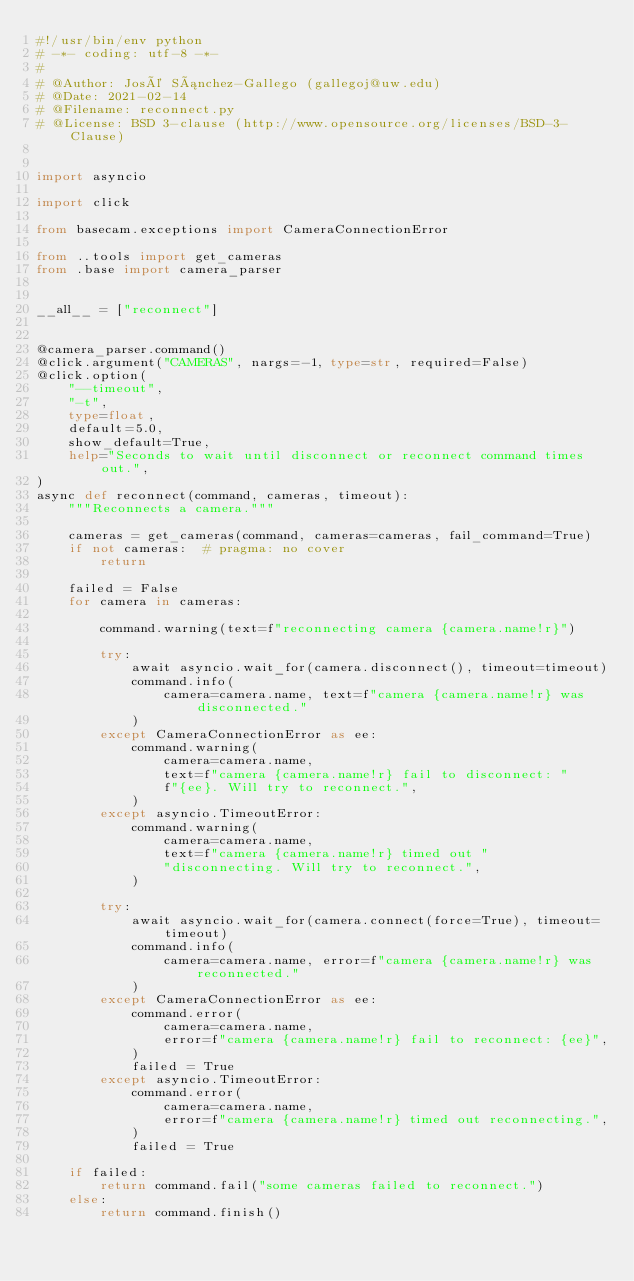Convert code to text. <code><loc_0><loc_0><loc_500><loc_500><_Python_>#!/usr/bin/env python
# -*- coding: utf-8 -*-
#
# @Author: José Sánchez-Gallego (gallegoj@uw.edu)
# @Date: 2021-02-14
# @Filename: reconnect.py
# @License: BSD 3-clause (http://www.opensource.org/licenses/BSD-3-Clause)


import asyncio

import click

from basecam.exceptions import CameraConnectionError

from ..tools import get_cameras
from .base import camera_parser


__all__ = ["reconnect"]


@camera_parser.command()
@click.argument("CAMERAS", nargs=-1, type=str, required=False)
@click.option(
    "--timeout",
    "-t",
    type=float,
    default=5.0,
    show_default=True,
    help="Seconds to wait until disconnect or reconnect command times out.",
)
async def reconnect(command, cameras, timeout):
    """Reconnects a camera."""

    cameras = get_cameras(command, cameras=cameras, fail_command=True)
    if not cameras:  # pragma: no cover
        return

    failed = False
    for camera in cameras:

        command.warning(text=f"reconnecting camera {camera.name!r}")

        try:
            await asyncio.wait_for(camera.disconnect(), timeout=timeout)
            command.info(
                camera=camera.name, text=f"camera {camera.name!r} was disconnected."
            )
        except CameraConnectionError as ee:
            command.warning(
                camera=camera.name,
                text=f"camera {camera.name!r} fail to disconnect: "
                f"{ee}. Will try to reconnect.",
            )
        except asyncio.TimeoutError:
            command.warning(
                camera=camera.name,
                text=f"camera {camera.name!r} timed out "
                "disconnecting. Will try to reconnect.",
            )

        try:
            await asyncio.wait_for(camera.connect(force=True), timeout=timeout)
            command.info(
                camera=camera.name, error=f"camera {camera.name!r} was reconnected."
            )
        except CameraConnectionError as ee:
            command.error(
                camera=camera.name,
                error=f"camera {camera.name!r} fail to reconnect: {ee}",
            )
            failed = True
        except asyncio.TimeoutError:
            command.error(
                camera=camera.name,
                error=f"camera {camera.name!r} timed out reconnecting.",
            )
            failed = True

    if failed:
        return command.fail("some cameras failed to reconnect.")
    else:
        return command.finish()
</code> 